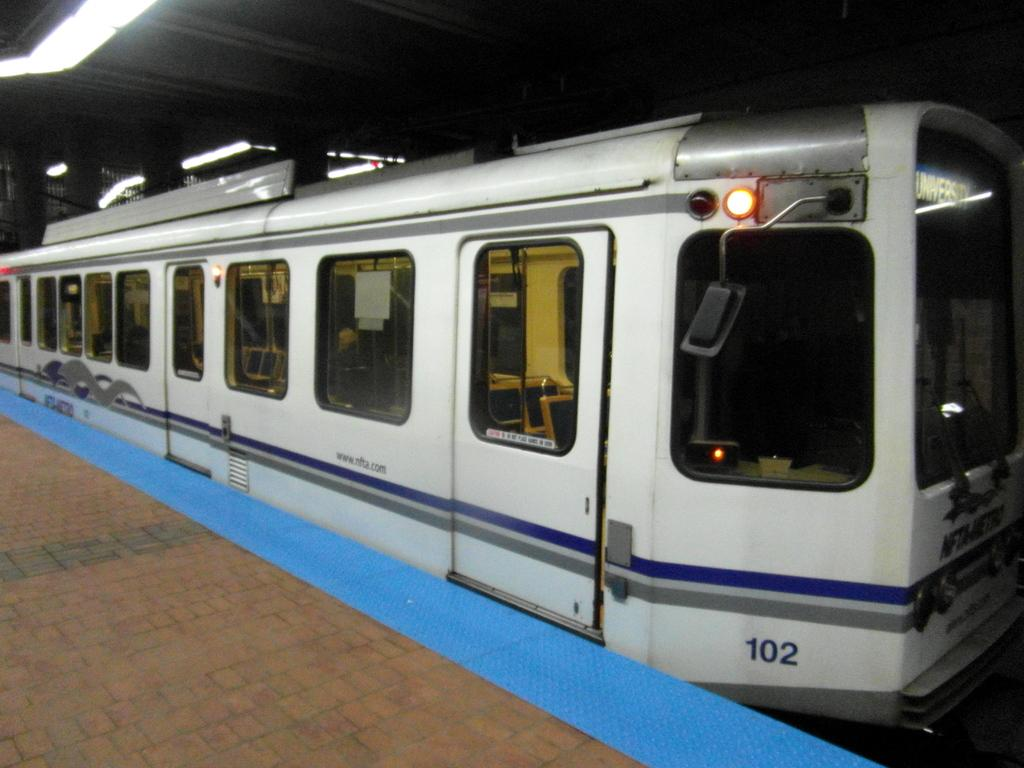What structure is present in the image? There is a platform in the image. What mode of transportation can be seen on the platform? There is a train in the image. What can be seen at the top of the image? There are lights visible at the top of the image. Where are the dolls placed on the platform in the image? There are no dolls present in the image. What type of material is the straw made of in the image? There is no straw present in the image. 